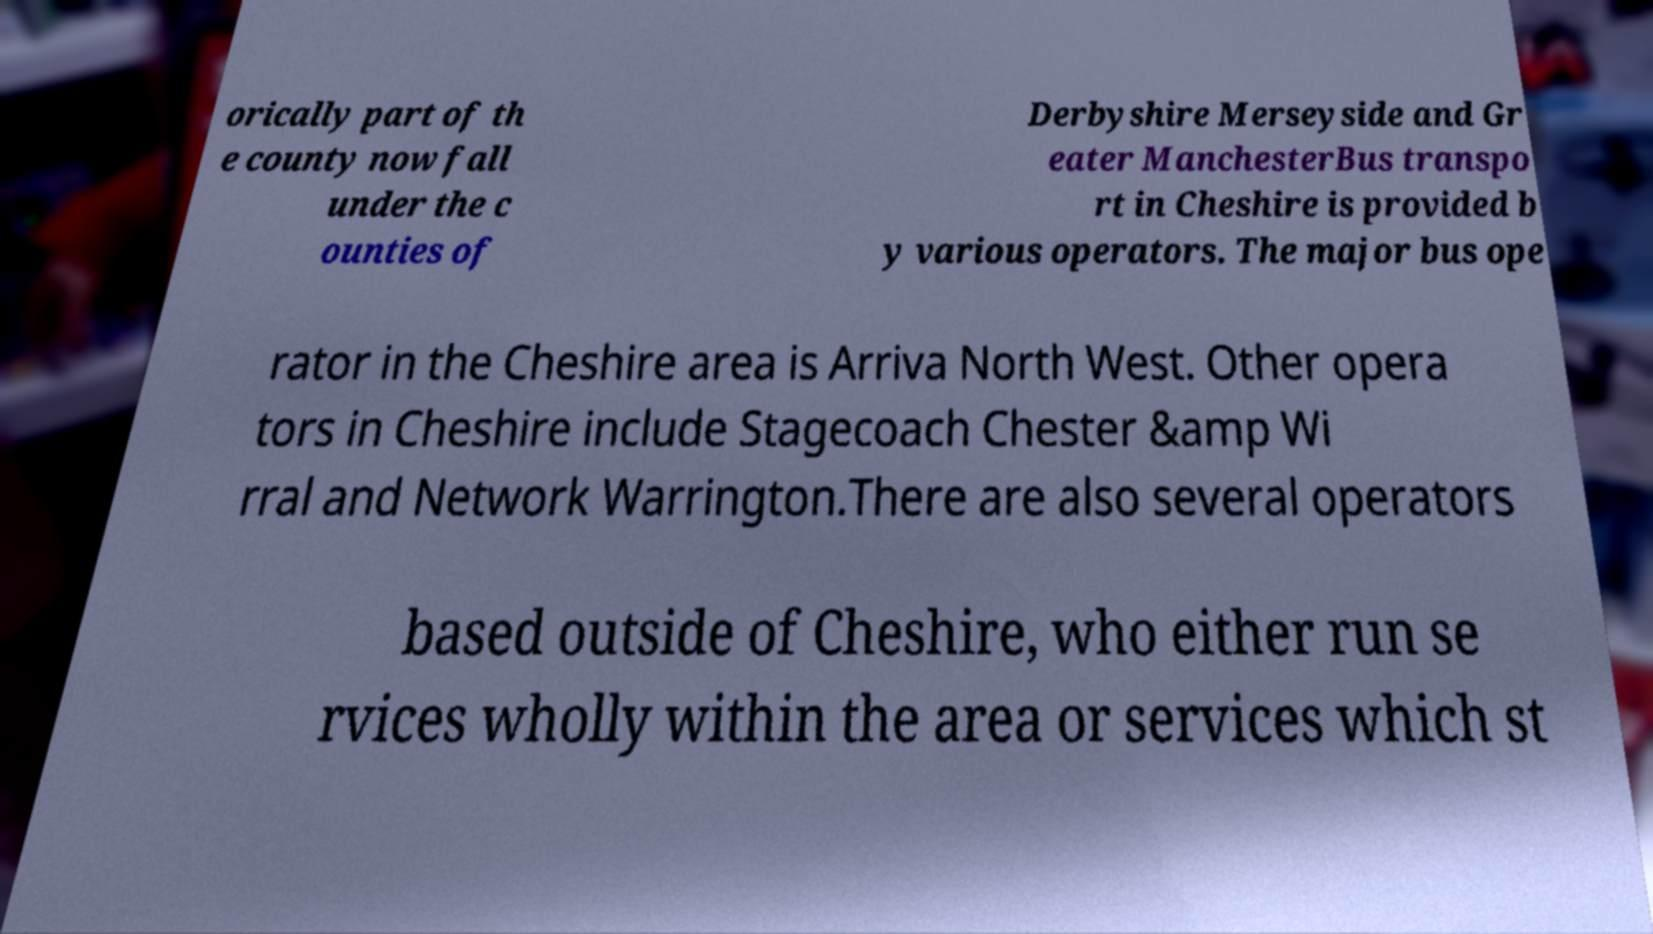Please read and relay the text visible in this image. What does it say? orically part of th e county now fall under the c ounties of Derbyshire Merseyside and Gr eater ManchesterBus transpo rt in Cheshire is provided b y various operators. The major bus ope rator in the Cheshire area is Arriva North West. Other opera tors in Cheshire include Stagecoach Chester &amp Wi rral and Network Warrington.There are also several operators based outside of Cheshire, who either run se rvices wholly within the area or services which st 